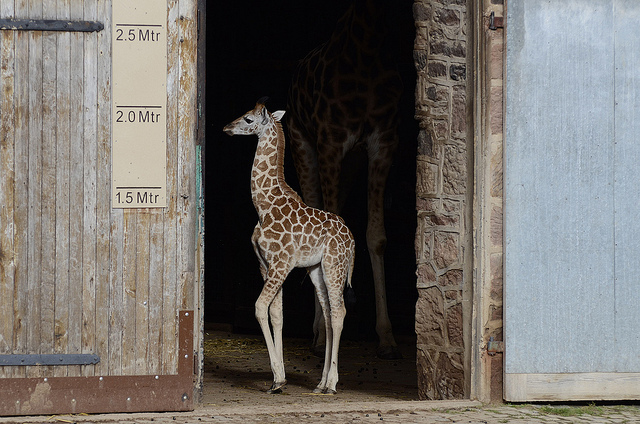Please transcribe the text information in this image. 2.5 Mtr 2.0 Mtr Mtr 1.5 